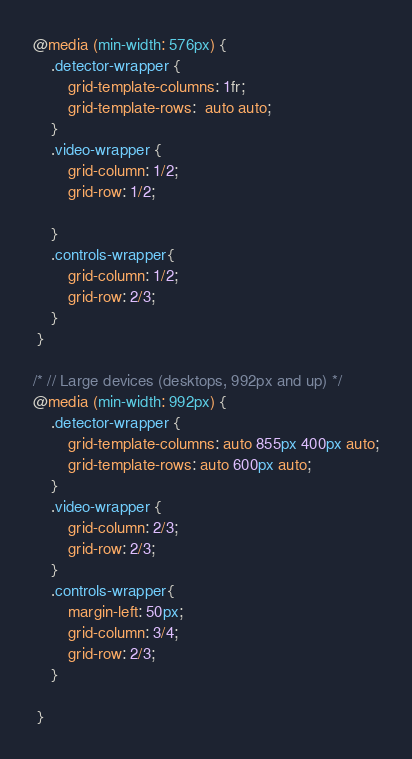Convert code to text. <code><loc_0><loc_0><loc_500><loc_500><_CSS_>@media (min-width: 576px) {
    .detector-wrapper {
        grid-template-columns: 1fr;
        grid-template-rows:  auto auto;
    }
    .video-wrapper {
        grid-column: 1/2;
        grid-row: 1/2;

    }
    .controls-wrapper{
        grid-column: 1/2;
        grid-row: 2/3;
    }
 }

/* // Large devices (desktops, 992px and up) */
@media (min-width: 992px) { 
    .detector-wrapper {
        grid-template-columns: auto 855px 400px auto;
        grid-template-rows: auto 600px auto;
    }
    .video-wrapper {
        grid-column: 2/3;
        grid-row: 2/3;
    }
    .controls-wrapper{
        margin-left: 50px;
        grid-column: 3/4;
        grid-row: 2/3;
    }

 }</code> 